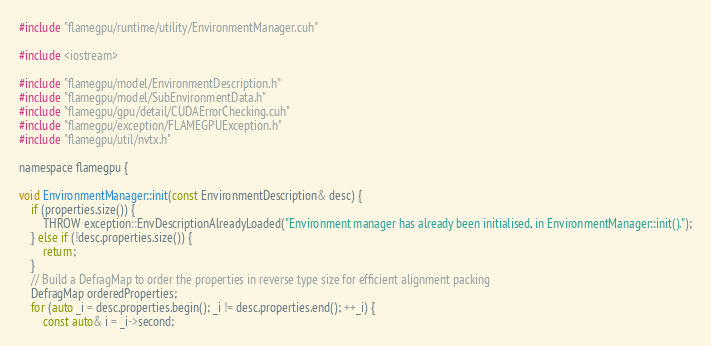<code> <loc_0><loc_0><loc_500><loc_500><_Cuda_>#include "flamegpu/runtime/utility/EnvironmentManager.cuh"

#include <iostream>

#include "flamegpu/model/EnvironmentDescription.h"
#include "flamegpu/model/SubEnvironmentData.h"
#include "flamegpu/gpu/detail/CUDAErrorChecking.cuh"
#include "flamegpu/exception/FLAMEGPUException.h"
#include "flamegpu/util/nvtx.h"

namespace flamegpu {

void EnvironmentManager::init(const EnvironmentDescription& desc) {
    if (properties.size()) {
        THROW exception::EnvDescriptionAlreadyLoaded("Environment manager has already been initialised, in EnvironmentManager::init().");
    } else if (!desc.properties.size()) {
        return;
    }
    // Build a DefragMap to order the properties in reverse type size for efficient alignment packing
    DefragMap orderedProperties;
    for (auto _i = desc.properties.begin(); _i != desc.properties.end(); ++_i) {
        const auto& i = _i->second;</code> 